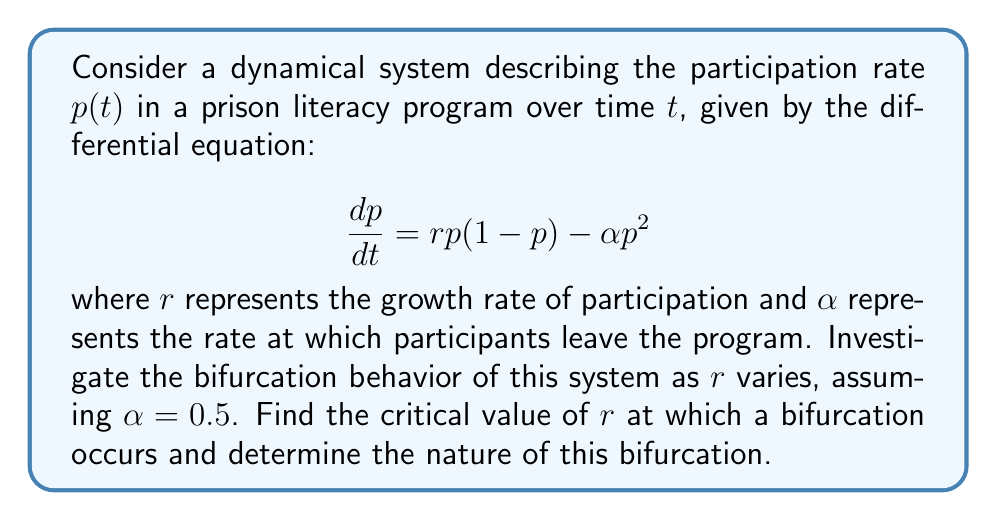Could you help me with this problem? 1) First, we need to find the equilibrium points of the system by setting $\frac{dp}{dt} = 0$:

   $$rp(1-p) - 0.5p^2 = 0$$

2) Factoring out $p$:

   $$p(r - rp - 0.5p) = 0$$

3) Solving this equation, we get two equilibrium points:

   $p_1 = 0$ and $p_2 = \frac{2r-1}{2r+1}$

4) The second equilibrium point $p_2$ only exists when $r > 0.5$, as $p$ must be non-negative.

5) To determine the stability of these equilibrium points, we need to evaluate the derivative of $\frac{dp}{dt}$ with respect to $p$:

   $$\frac{d}{dp}\left(\frac{dp}{dt}\right) = r(1-2p) - p$$

6) At $p_1 = 0$, the derivative is $r$. This equilibrium is stable when $r < 0$ and unstable when $r > 0$.

7) At $p_2 = \frac{2r-1}{2r+1}$, the derivative is $-r + \frac{1}{2}$. This equilibrium is stable when $r > 0.5$.

8) A bifurcation occurs when the stability of the equilibrium points changes. This happens at $r = 0.5$.

9) When $r < 0.5$, there is only one equilibrium point ($p_1 = 0$) which is stable.
   When $r > 0.5$, $p_1 = 0$ becomes unstable, and a new stable equilibrium $p_2$ appears.

10) This type of bifurcation, where a stable equilibrium point becomes unstable and a new stable equilibrium point emerges, is called a transcritical bifurcation.
Answer: Transcritical bifurcation at $r = 0.5$ 